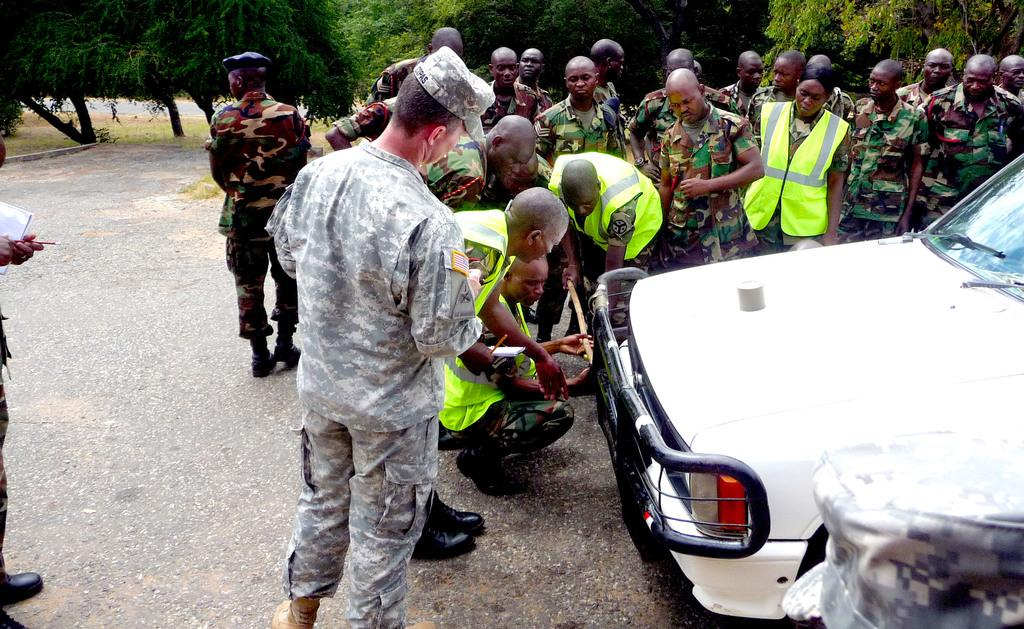What are the people in the image doing? There are soldiers standing in the image. What type of vehicle is present in the image? There is a white car in the image. What type of vegetation is visible in the image? There are green trees in the image. Can you tell me how many dogs are sitting on the white car in the image? There are no dogs present in the image; it features soldiers and a white car. What type of rifle is being used by the soldiers in the image? There is no rifle visible in the image; only soldiers and a white car are present. 